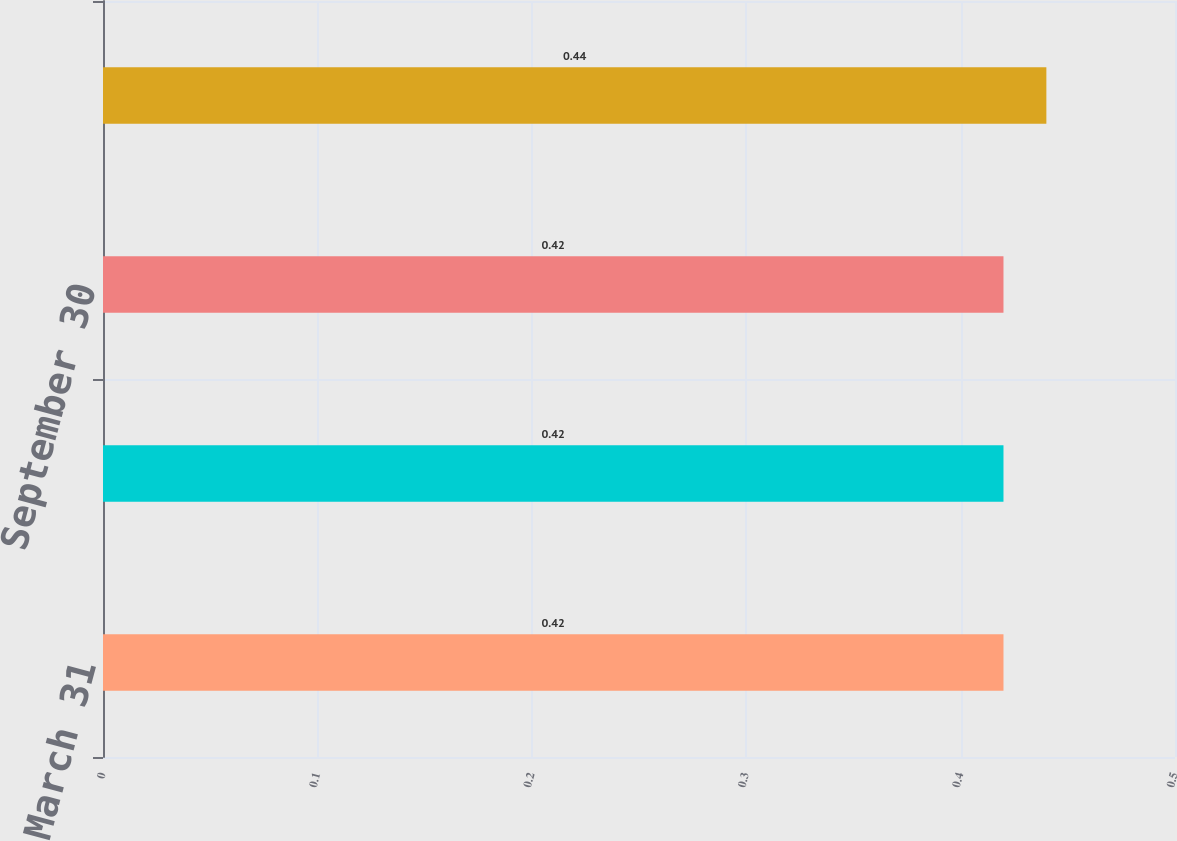Convert chart to OTSL. <chart><loc_0><loc_0><loc_500><loc_500><bar_chart><fcel>March 31<fcel>June 30<fcel>September 30<fcel>December 31<nl><fcel>0.42<fcel>0.42<fcel>0.42<fcel>0.44<nl></chart> 